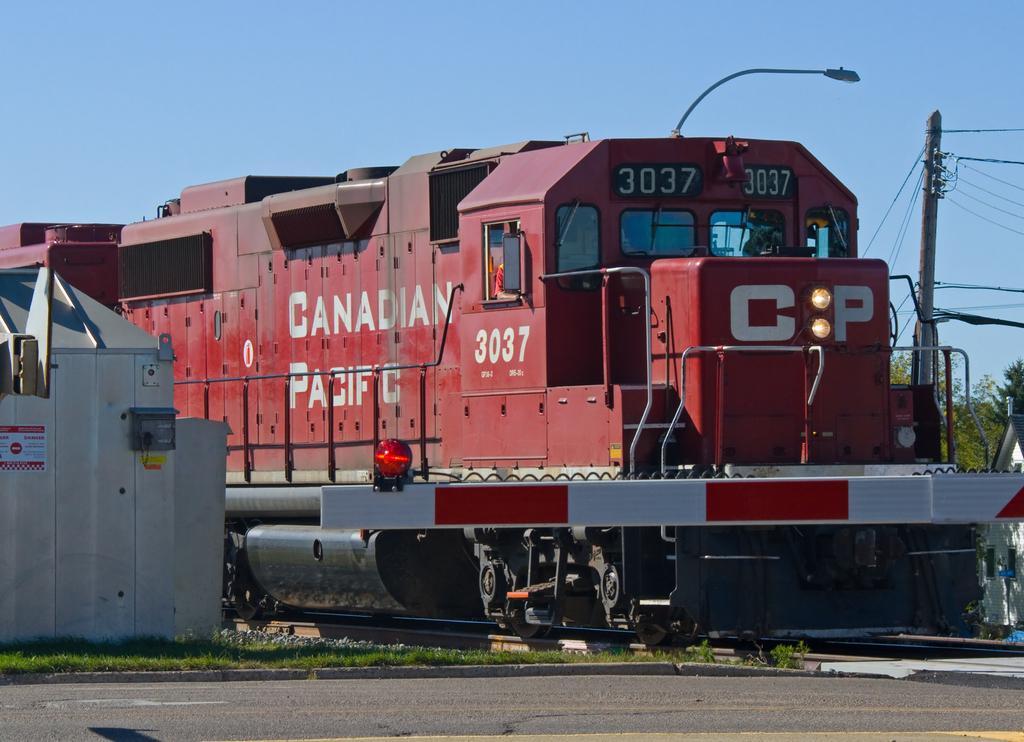Can you describe this image briefly? In this image we can see a train on the railway track. In the background we can see sky, street light, pole, electric cables, trees, grass and road. 